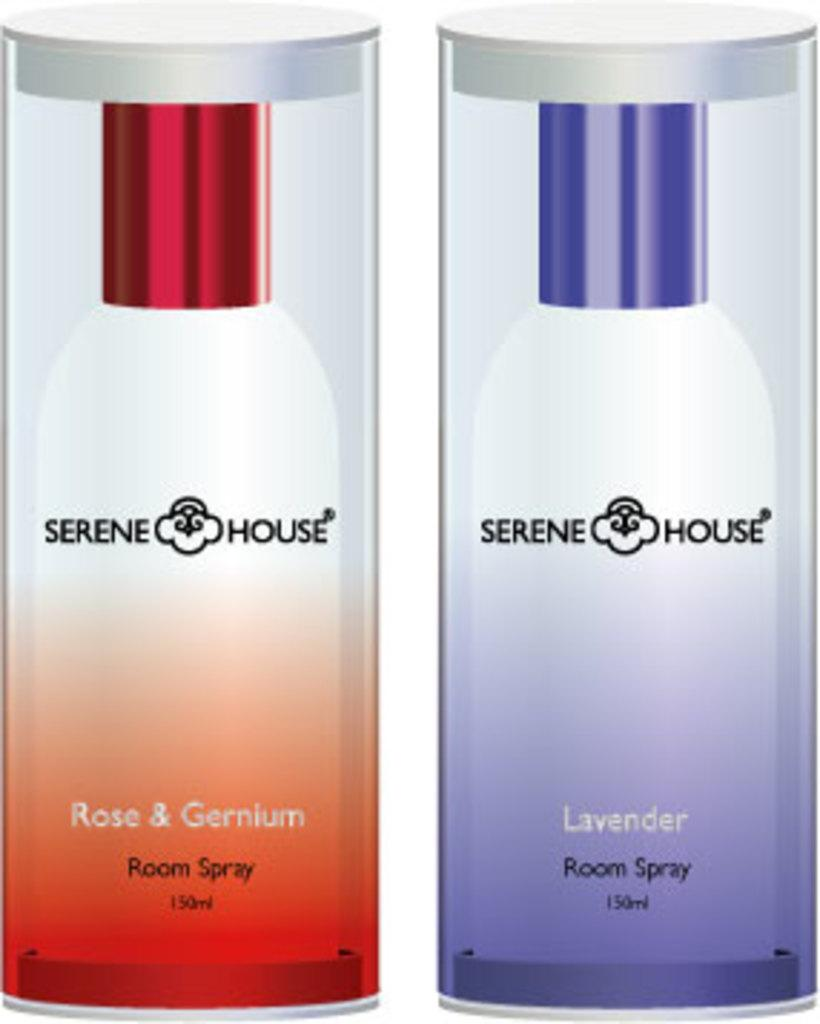<image>
Provide a brief description of the given image. Two containers of room spray by Serene House. 